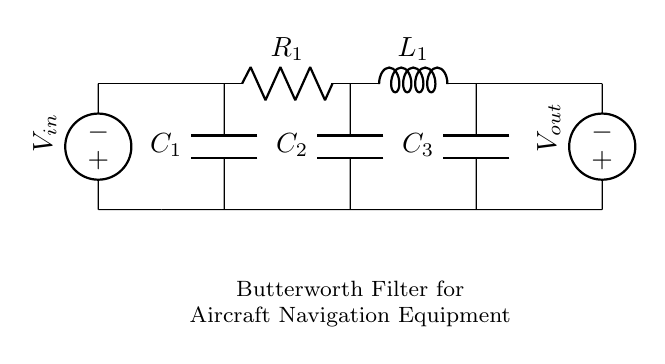What type of filter is represented in the circuit? The circuit diagram clearly labels the design as a Butterworth filter. It is characterized by its smooth frequency response and is commonly used in signal processing applications.
Answer: Butterworth filter How many capacitors are present in the circuit? By examining the diagram, there are three components labeled as capacitors (C1, C2, C3) connected in parallel alongside other components.
Answer: Three What is the role of the inductor in this filter? The inductor (L1) is a key component in the Butterworth filter that, in conjunction with the resistors and capacitors, helps to determine the cutoff frequency. Its primary function is to store energy in a magnetic field and resist changes in current.
Answer: Store energy Which component causes the phase shift in this filter? Capacitors (C1, C2, C3) and the inductor (L1) in the circuit contribute to the phase shift by affecting the impedance at different frequencies, altering the phase relationship between voltage and current.
Answer: Capacitors and inductor What is the function of the voltage source labeled Vout? Vout represents the output voltage from the filter circuit indicating the response after the signal has been processed through the system. It reflects the filtered output signal based on the input voltage (Vin).
Answer: Output signal 